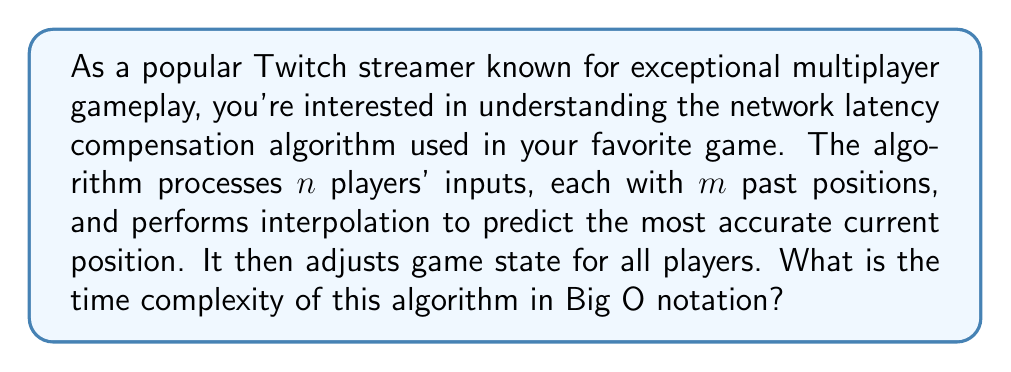Teach me how to tackle this problem. Let's break down the algorithm and analyze its time complexity:

1. Processing inputs:
   - There are $n$ players
   - Each player has $m$ past positions
   - Time complexity for this step: $O(n \cdot m)$

2. Interpolation:
   - For each player, we need to interpolate based on their past positions
   - Assuming a simple linear interpolation, this takes $O(m)$ time per player
   - Time complexity for this step: $O(n \cdot m)$

3. Adjusting game state:
   - We need to update the game state for all $n$ players
   - Assuming a constant time operation per player, this takes $O(n)$ time

Total time complexity:
$$O(n \cdot m) + O(n \cdot m) + O(n) = O(n \cdot m + n) = O(n \cdot m)$$

The last step of simplification to $O(n \cdot m)$ is valid because $n \cdot m$ dominates $n$ for any $m > 1$, which is typically the case in real-world scenarios where we consider multiple past positions.

This time complexity indicates that the algorithm's performance scales linearly with both the number of players and the number of past positions considered for each player.
Answer: $O(n \cdot m)$, where $n$ is the number of players and $m$ is the number of past positions considered for each player. 